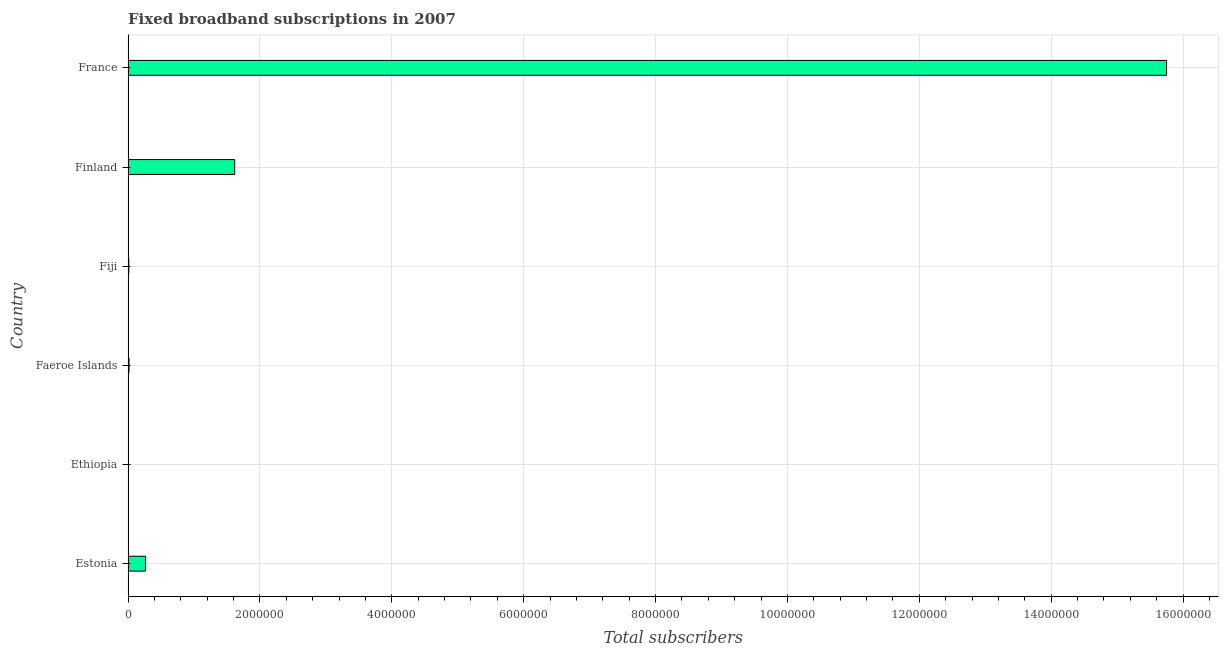Does the graph contain any zero values?
Your answer should be very brief. No. What is the title of the graph?
Your answer should be compact. Fixed broadband subscriptions in 2007. What is the label or title of the X-axis?
Your answer should be compact. Total subscribers. What is the label or title of the Y-axis?
Provide a succinct answer. Country. What is the total number of fixed broadband subscriptions in Finland?
Your answer should be compact. 1.62e+06. Across all countries, what is the maximum total number of fixed broadband subscriptions?
Your answer should be very brief. 1.58e+07. Across all countries, what is the minimum total number of fixed broadband subscriptions?
Your answer should be compact. 1036. In which country was the total number of fixed broadband subscriptions maximum?
Offer a terse response. France. In which country was the total number of fixed broadband subscriptions minimum?
Your answer should be very brief. Ethiopia. What is the sum of the total number of fixed broadband subscriptions?
Make the answer very short. 1.77e+07. What is the difference between the total number of fixed broadband subscriptions in Estonia and Finland?
Provide a succinct answer. -1.35e+06. What is the average total number of fixed broadband subscriptions per country?
Ensure brevity in your answer.  2.94e+06. What is the median total number of fixed broadband subscriptions?
Make the answer very short. 1.40e+05. In how many countries, is the total number of fixed broadband subscriptions greater than 10400000 ?
Provide a succinct answer. 1. What is the ratio of the total number of fixed broadband subscriptions in Estonia to that in Fiji?
Your answer should be compact. 23.04. Is the total number of fixed broadband subscriptions in Faeroe Islands less than that in Fiji?
Offer a very short reply. No. What is the difference between the highest and the second highest total number of fixed broadband subscriptions?
Provide a succinct answer. 1.41e+07. Is the sum of the total number of fixed broadband subscriptions in Fiji and Finland greater than the maximum total number of fixed broadband subscriptions across all countries?
Keep it short and to the point. No. What is the difference between the highest and the lowest total number of fixed broadband subscriptions?
Your response must be concise. 1.57e+07. How many bars are there?
Offer a terse response. 6. Are all the bars in the graph horizontal?
Keep it short and to the point. Yes. What is the difference between two consecutive major ticks on the X-axis?
Provide a short and direct response. 2.00e+06. Are the values on the major ticks of X-axis written in scientific E-notation?
Provide a short and direct response. No. What is the Total subscribers of Estonia?
Keep it short and to the point. 2.65e+05. What is the Total subscribers in Ethiopia?
Ensure brevity in your answer.  1036. What is the Total subscribers of Faeroe Islands?
Keep it short and to the point. 1.45e+04. What is the Total subscribers in Fiji?
Provide a short and direct response. 1.15e+04. What is the Total subscribers of Finland?
Offer a very short reply. 1.62e+06. What is the Total subscribers in France?
Make the answer very short. 1.58e+07. What is the difference between the Total subscribers in Estonia and Ethiopia?
Give a very brief answer. 2.64e+05. What is the difference between the Total subscribers in Estonia and Faeroe Islands?
Provide a short and direct response. 2.50e+05. What is the difference between the Total subscribers in Estonia and Fiji?
Provide a short and direct response. 2.53e+05. What is the difference between the Total subscribers in Estonia and Finland?
Provide a short and direct response. -1.35e+06. What is the difference between the Total subscribers in Estonia and France?
Your answer should be very brief. -1.55e+07. What is the difference between the Total subscribers in Ethiopia and Faeroe Islands?
Provide a short and direct response. -1.34e+04. What is the difference between the Total subscribers in Ethiopia and Fiji?
Keep it short and to the point. -1.05e+04. What is the difference between the Total subscribers in Ethiopia and Finland?
Your answer should be very brief. -1.62e+06. What is the difference between the Total subscribers in Ethiopia and France?
Provide a short and direct response. -1.57e+07. What is the difference between the Total subscribers in Faeroe Islands and Fiji?
Ensure brevity in your answer.  2963. What is the difference between the Total subscribers in Faeroe Islands and Finland?
Your response must be concise. -1.60e+06. What is the difference between the Total subscribers in Faeroe Islands and France?
Offer a terse response. -1.57e+07. What is the difference between the Total subscribers in Fiji and Finland?
Give a very brief answer. -1.61e+06. What is the difference between the Total subscribers in Fiji and France?
Provide a short and direct response. -1.57e+07. What is the difference between the Total subscribers in Finland and France?
Make the answer very short. -1.41e+07. What is the ratio of the Total subscribers in Estonia to that in Ethiopia?
Offer a very short reply. 255.74. What is the ratio of the Total subscribers in Estonia to that in Faeroe Islands?
Your answer should be compact. 18.32. What is the ratio of the Total subscribers in Estonia to that in Fiji?
Ensure brevity in your answer.  23.04. What is the ratio of the Total subscribers in Estonia to that in Finland?
Keep it short and to the point. 0.16. What is the ratio of the Total subscribers in Estonia to that in France?
Give a very brief answer. 0.02. What is the ratio of the Total subscribers in Ethiopia to that in Faeroe Islands?
Make the answer very short. 0.07. What is the ratio of the Total subscribers in Ethiopia to that in Fiji?
Offer a very short reply. 0.09. What is the ratio of the Total subscribers in Ethiopia to that in Finland?
Your answer should be compact. 0. What is the ratio of the Total subscribers in Faeroe Islands to that in Fiji?
Your answer should be very brief. 1.26. What is the ratio of the Total subscribers in Faeroe Islands to that in Finland?
Your answer should be very brief. 0.01. What is the ratio of the Total subscribers in Fiji to that in Finland?
Offer a terse response. 0.01. What is the ratio of the Total subscribers in Fiji to that in France?
Your answer should be compact. 0. What is the ratio of the Total subscribers in Finland to that in France?
Provide a short and direct response. 0.1. 